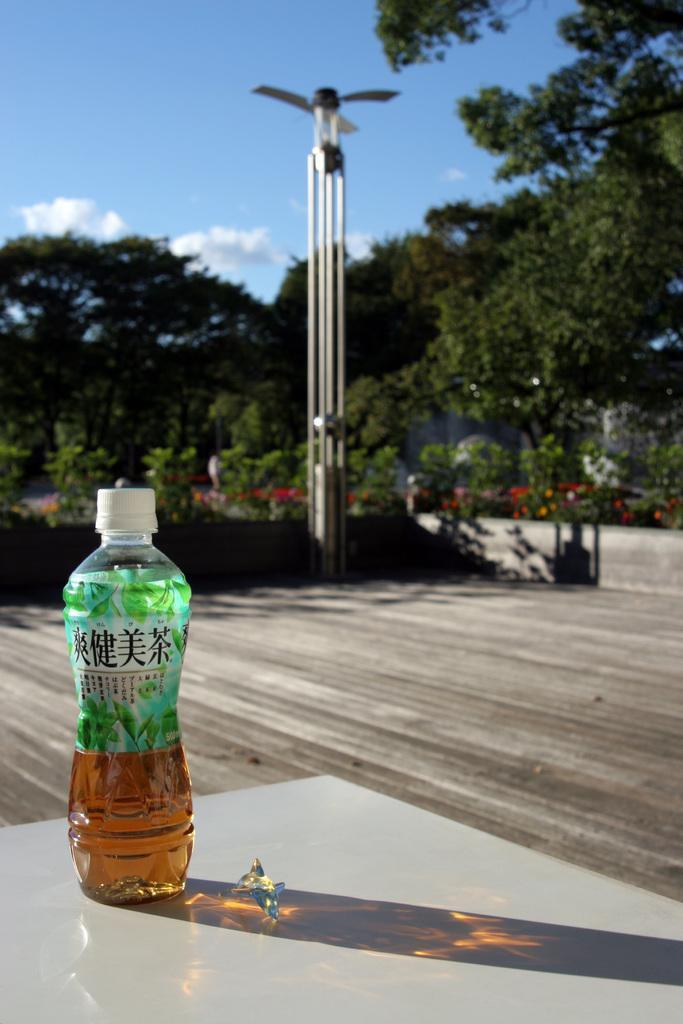Could you give a brief overview of what you see in this image? In this picture we can see a bottle with drink in it placed on table and ion background we can see path, pole, trees, sky with clouds. 